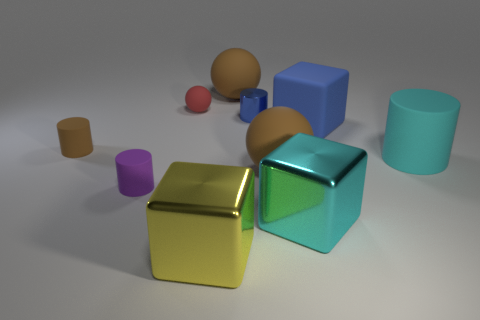Can you tell me more about the different shapes and colors present in this image? Certainly! The image features a variety of geometric shapes including cylinders, cubes, and spheres, rendered in colors such as purple, cyan, gold, and shades of brown and red. These elements are arranged in a seemingly random fashion across a flat surface, which could suggest a theme of diversity or an exercise in shape recognition. 